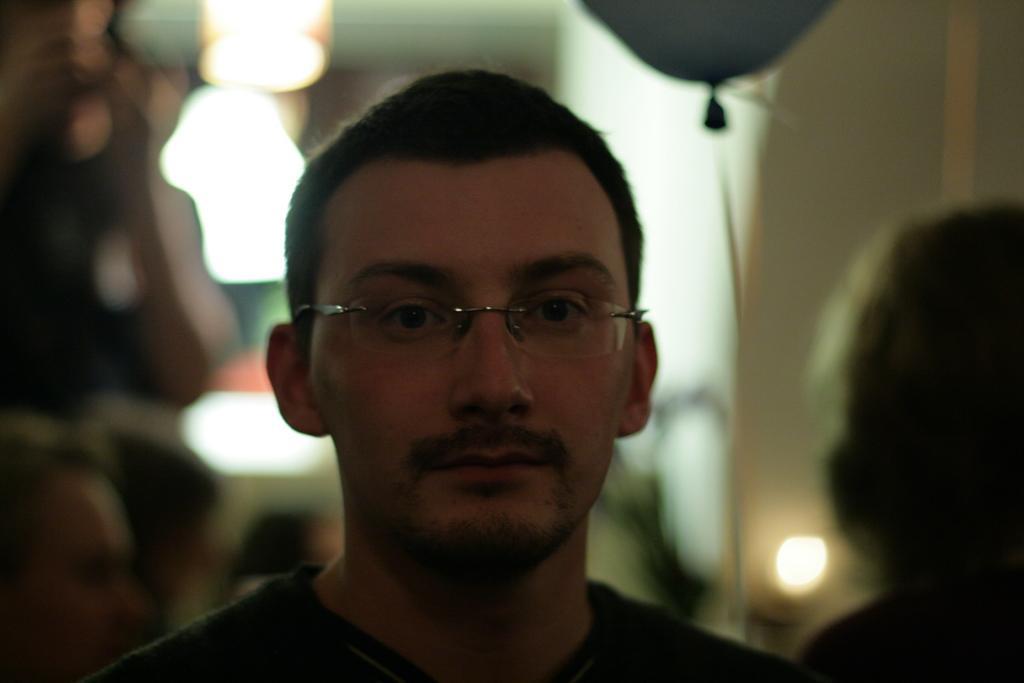How would you summarize this image in a sentence or two? In the picture I can see person wearing spectacles, behind we can see few people and also focusing lights. 